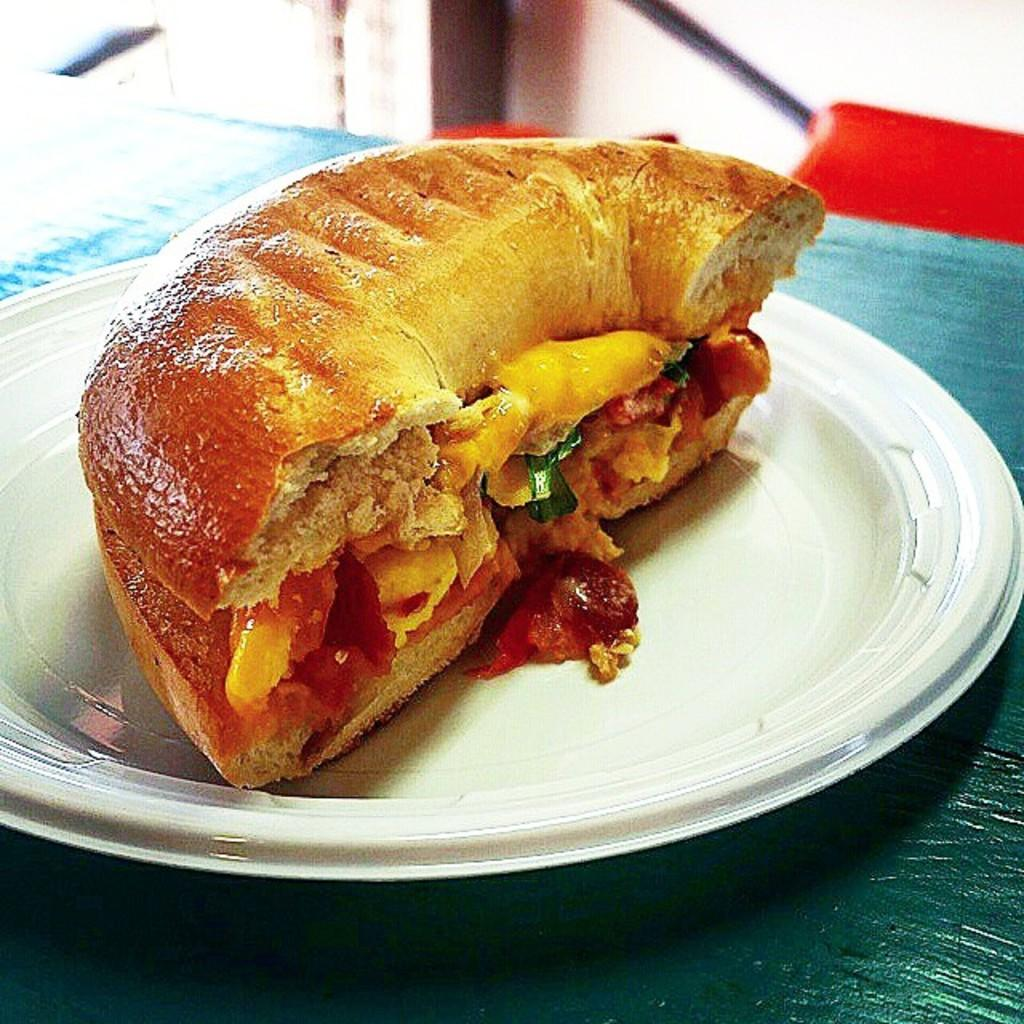What type of food can be seen in the image? There is food in the image, and it is in brown color. What color is the plate that holds the food? The plate is in white color. On what surface is the plate placed? The plate is on a green surface. How many stars can be seen on the feet of the person in the image? There is no person or stars present in the image; it only features food, a plate, and a green surface. 